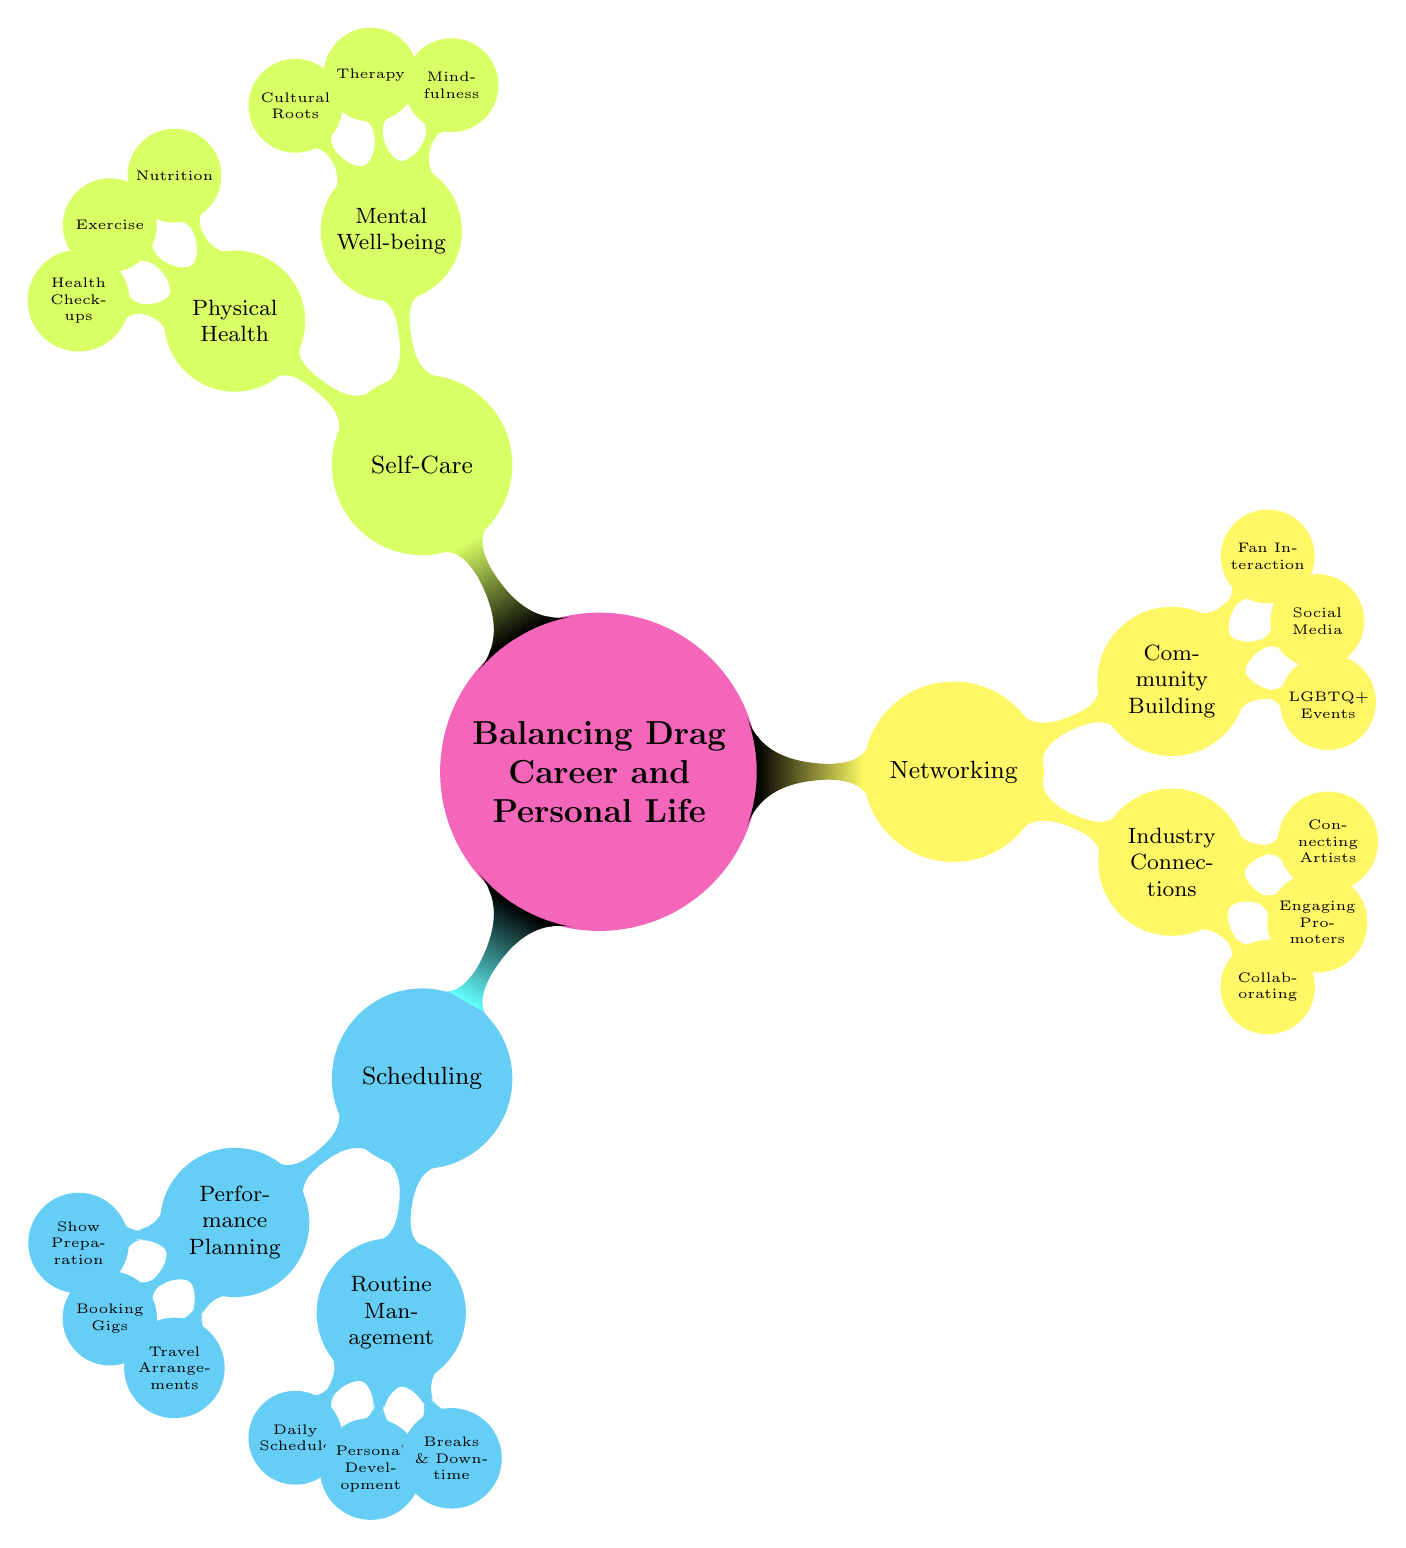What's the main title of the mind map? The title is explicitly labeled at the center of the diagram, indicating the primary focus of the mind map.
Answer: Balancing Drag Career and Personal Life How many main nodes are there in the diagram? The diagram branches out into three main nodes: Scheduling, Networking, and Self-Care. This can be counted directly from the branches extending from the central node.
Answer: 3 What is one of the activities under "Performance Planning"? Examining the first child node under "Performance Planning" reveals specific activities associated with this category. One of those activities is listed.
Answer: Show Preparation Which node relates to community support in the networking category? The sub-node under Networking representing support activities is labeled "Community Building," which includes elements related to community support.
Answer: Community Building Which aspect of self-care focuses on maintaining mental health? The mind map identifies "Mental Well-being" as a specific node under the Self-Care category, indicating its relevance to mental health maintenance.
Answer: Mental Well-being What do you do to balance personal development in your routine? The diagram specifies "Time for Personal Development" as a key node under "Routine Management," illustrating activities related to skill enhancement and personal growth.
Answer: Time for Personal Development How many activities are listed under the "Industry Connections" node? Counting the child nodes under the "Industry Connections" section reveals three activities related to building connections in the drag industry.
Answer: 3 What is the relationship between Networking and Community Building? Networking serves as a primary node that branches out to "Community Building," indicating that building relationships with the community is a critical aspect of networking in the drag field.
Answer: Networking leads to Community Building Which subcategory encompasses mindfulness practices? Within the Self-Care category, the node addressing mindfulness is categorized under "Mental Well-being," clarifying where mindfulness practices are discussed.
Answer: Mental Well-being 